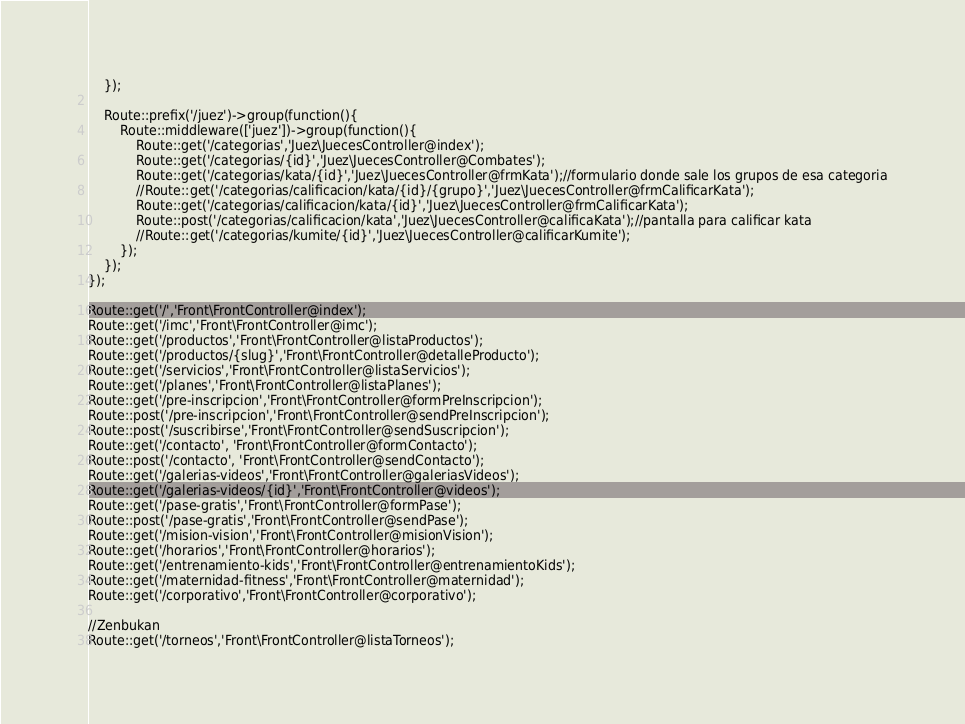Convert code to text. <code><loc_0><loc_0><loc_500><loc_500><_PHP_>    });

    Route::prefix('/juez')->group(function(){
        Route::middleware(['juez'])->group(function(){
            Route::get('/categorias','Juez\JuecesController@index');
            Route::get('/categorias/{id}','Juez\JuecesController@Combates');
            Route::get('/categorias/kata/{id}','Juez\JuecesController@frmKata');//formulario donde sale los grupos de esa categoria
            //Route::get('/categorias/calificacion/kata/{id}/{grupo}','Juez\JuecesController@frmCalificarKata');
            Route::get('/categorias/calificacion/kata/{id}','Juez\JuecesController@frmCalificarKata');
            Route::post('/categorias/calificacion/kata','Juez\JuecesController@calificaKata');//pantalla para calificar kata
            //Route::get('/categorias/kumite/{id}','Juez\JuecesController@calificarKumite');
        });
    });
});

Route::get('/','Front\FrontController@index');
Route::get('/imc','Front\FrontController@imc');
Route::get('/productos','Front\FrontController@listaProductos');
Route::get('/productos/{slug}','Front\FrontController@detalleProducto');
Route::get('/servicios','Front\FrontController@listaServicios');
Route::get('/planes','Front\FrontController@listaPlanes');
Route::get('/pre-inscripcion','Front\FrontController@formPreInscripcion');
Route::post('/pre-inscripcion','Front\FrontController@sendPreInscripcion');
Route::post('/suscribirse','Front\FrontController@sendSuscripcion');
Route::get('/contacto', 'Front\FrontController@formContacto');
Route::post('/contacto', 'Front\FrontController@sendContacto');
Route::get('/galerias-videos','Front\FrontController@galeriasVideos');
Route::get('/galerias-videos/{id}','Front\FrontController@videos');
Route::get('/pase-gratis','Front\FrontController@formPase');
Route::post('/pase-gratis','Front\FrontController@sendPase');
Route::get('/mision-vision','Front\FrontController@misionVision');
Route::get('/horarios','Front\FrontController@horarios');
Route::get('/entrenamiento-kids','Front\FrontController@entrenamientoKids');
Route::get('/maternidad-fitness','Front\FrontController@maternidad');
Route::get('/corporativo','Front\FrontController@corporativo');

//Zenbukan
Route::get('/torneos','Front\FrontController@listaTorneos');</code> 